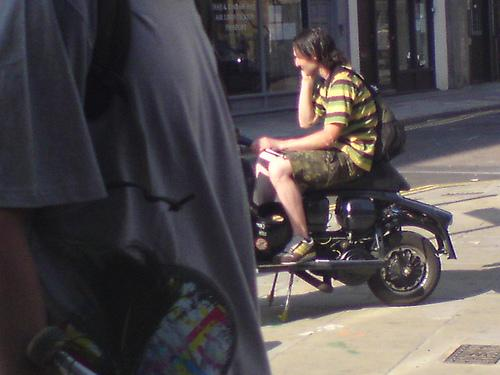Identify the object casting a shadow on the pavement in the image. The motorcycle has cast a shadow on the pavement. Briefly describe the state of the man's hair in the picture. The man has medium to long-length hair. Estimate the number of different colors in the man's shirt. The man's shirt has at least three different colors: red, purple, and yellow. Can you identify a specific feature about the man's shirt in the photograph? The man's shirt is multi-colored with a striped pattern consisting of brown, yellow, and green colors. Can you find any accessories that the man is wearing or carrying in the image? The man is wearing a backpack and carrying a bag in his hand. What type of clothing is the man wearing in the picture, besides his shirt and shorts? The man is also wearing a gray tee-shirt. What activity is the main subject engaged in, and what kind of vehicle is he using? The man is sitting on a motorcycle, talking on a cell phone. In the image, provide the details of the man's footwear. The man is wearing white, black, and yellow athletic shoes or tennis shoes. Describe the appearance of the windows in the background of the image. The background features tall glass store windows with writing on them. What type of pattern is on the man's shorts in the image? The man's shorts have a camouflage pattern. What is the relationship between the man and the cell phone? He is talking on it. Describe the shadow that is cast on the ground. motorcycle shadow: X:254 Y:250 Width:245 Height:245 What do you think the brand of the red skateboard leaning against the wall is? No, it's not mentioned in the image. How is the image quality in terms of lighting and details? good lighting and detailed What are the colors of the shirt the man is wearing? red, purple, yellow Identify the different areas of color or texture in the image. man's shirt, camouflage shorts, pavement, glass window, motorcycle Does the man have long or short hair? Medium length hair Are there any words that can be recognized from the writing on the glass window? No recognizable words. Identify any text or writing visible in the image and its location. Writing on glass window: X:211 Y:6 Width:47 Height:47 Which object is associated with the text "red purple yellow stripes"? The man's shirt What patterns can be found on the person's clothes? camouflage on shorts, stripes on the shirt Describe the interaction between the man and the motorcycle. The man is sitting on the motorcycle and talking on the phone. Does the image show a happy or sad emotion? Neutral to happy emotion Are there people or objects that are out of focus in the image? No, all objects are in focus. Is there text on the glass window? If yes, are the words readable? Yes, there is text but it is not readable. How is the man wearing the backpack? on his back, hanging low Determine the color and style of the man's shoes. white, black, yellow sneakers Are there any anomalous objects or occurrences in the image? no anomalies detected List object positions and sizes in the image. man in a striped shirt: X:280 Y:27 Width:125 Height:125, green camo shorts: X:275 Y:129 Width:102 Height:102, motorcycle: X:221 Y:30 Width:274 Height:274 